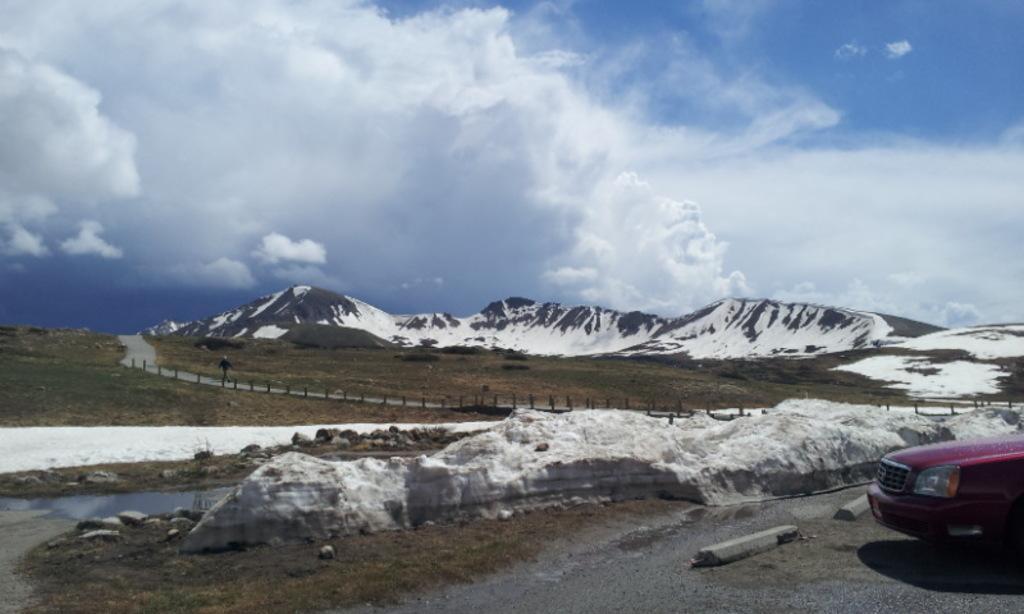Can you describe this image briefly? In this picture we can see a vehicle on the road and in the background we can see mountains,sky. 